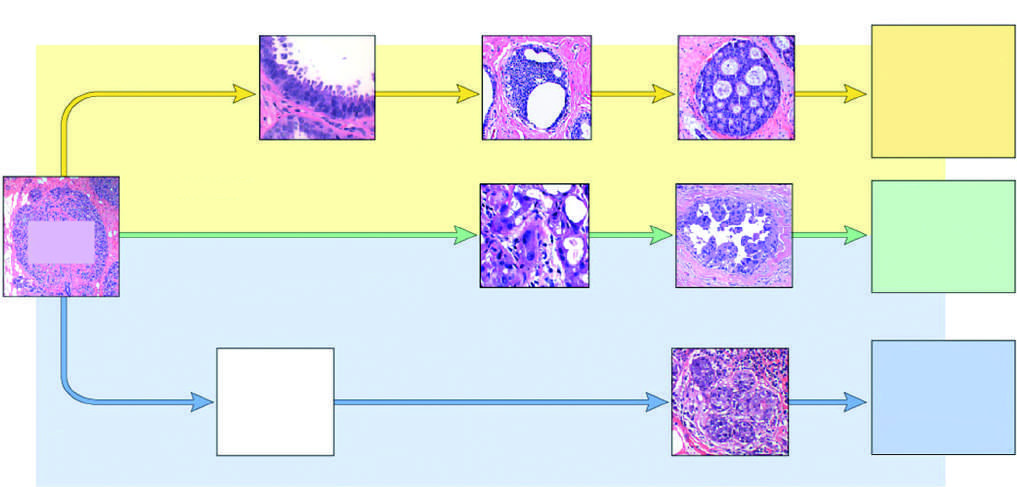s show flow cytometry the type of cancer that arises most commonly in individuals with germline brca2 mutations?
Answer the question using a single word or phrase. No 